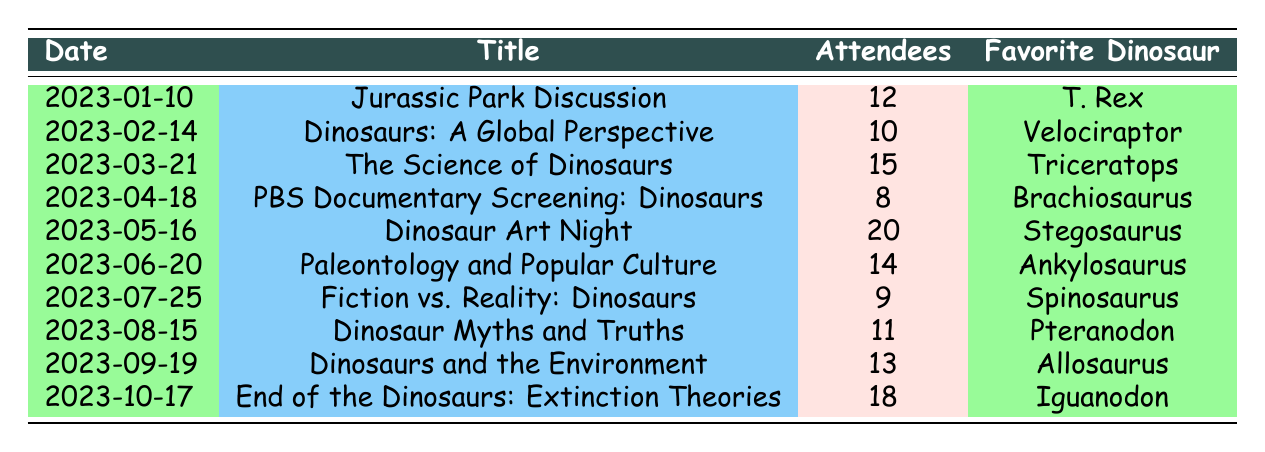What was the title of the meeting on March 21, 2023? The table shows the titles along with their corresponding dates. For March 21, 2023, the title listed is "The Science of Dinosaurs."
Answer: The Science of Dinosaurs How many attendees were present at the Dinosaur Art Night on May 16, 2023? The table indicates that the attendee count for the Dinosaur Art Night on May 16, 2023, is 20.
Answer: 20 Which meeting had the least number of attendees, and how many were there? By evaluating the attendee counts for all meetings, the lowest count is found under "PBS Documentary Screening: Dinosaurs" on April 18, 2023, with only 8 attendees.
Answer: PBS Documentary Screening: Dinosaurs, 8 What is the average number of attendees across all meetings in the table? To calculate the average, we add the total number of attendees: 12 + 10 + 15 + 8 + 20 + 14 + 9 + 11 + 13 + 18 =  140. We then divide by the number of meetings (10): 140/10 = 14.
Answer: 14 Did more people attend the "Dinosaurs: A Global Perspective" meeting than the "Dinosaur Myths and Truths" meeting? The member count for "Dinosaurs: A Global Perspective" is 10 and for "Dinosaur Myths and Truths" is 11. Therefore, based on these counts, fewer people attended the former.
Answer: No Which month had the highest attendance, and what was the count? Upon reviewing the table, May has the highest attendance for "Dinosaur Art Night" with 20 participants.
Answer: May, 20 How many total attendees were there for meetings that featured dinosaurs in their titles? We identify the relevant meetings: "Jurassic Park Discussion," "Dinosaurs: A Global Perspective," "The Science of Dinosaurs," "PBS Documentary Screening: Dinosaurs," "Dinosaur Art Night," "Paleontology and Popular Culture," "Fiction vs. Reality: Dinosaurs," "Dinosaur Myths and Truths," "Dinosaurs and the Environment," and "End of the Dinosaurs: Extinction Theories". Their attendee counts sum to 12 + 10 + 15 + 8 + 20 + 14 + 9 + 11 + 13 + 18 = 140.
Answer: 140 Is "Tyrannosaurus Rex" the favorite dinosaur for the most popular meeting in terms of attendee count? The most popular meeting in terms of attendance is "Dinosaur Art Night," with 20 attendees, and the favorite dinosaur listed for this meeting is "Stegosaurus." Therefore, "Tyrannosaurus Rex" is not the favorite for the most popular meeting.
Answer: No What were the favorite dinosaurs for the meetings held in June and October 2023? The favorite dinosaur for the June meeting ("Paleontology and Popular Culture") is "Ankylosaurus," and for the October meeting ("End of the Dinosaurs: Extinction Theories"), it is "Iguanodon."
Answer: Ankylosaurus, Iguanodon 